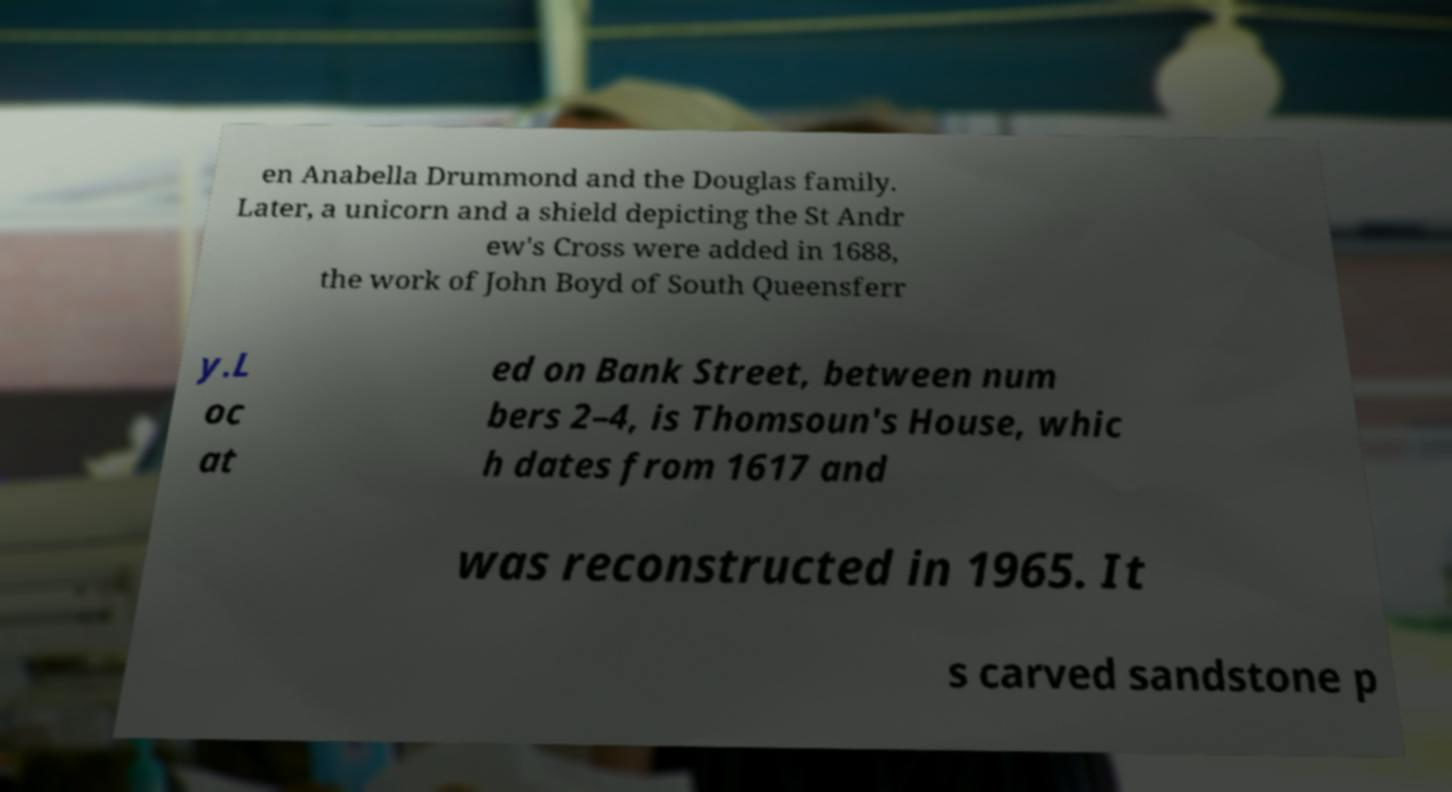Can you accurately transcribe the text from the provided image for me? en Anabella Drummond and the Douglas family. Later, a unicorn and a shield depicting the St Andr ew's Cross were added in 1688, the work of John Boyd of South Queensferr y.L oc at ed on Bank Street, between num bers 2–4, is Thomsoun's House, whic h dates from 1617 and was reconstructed in 1965. It s carved sandstone p 